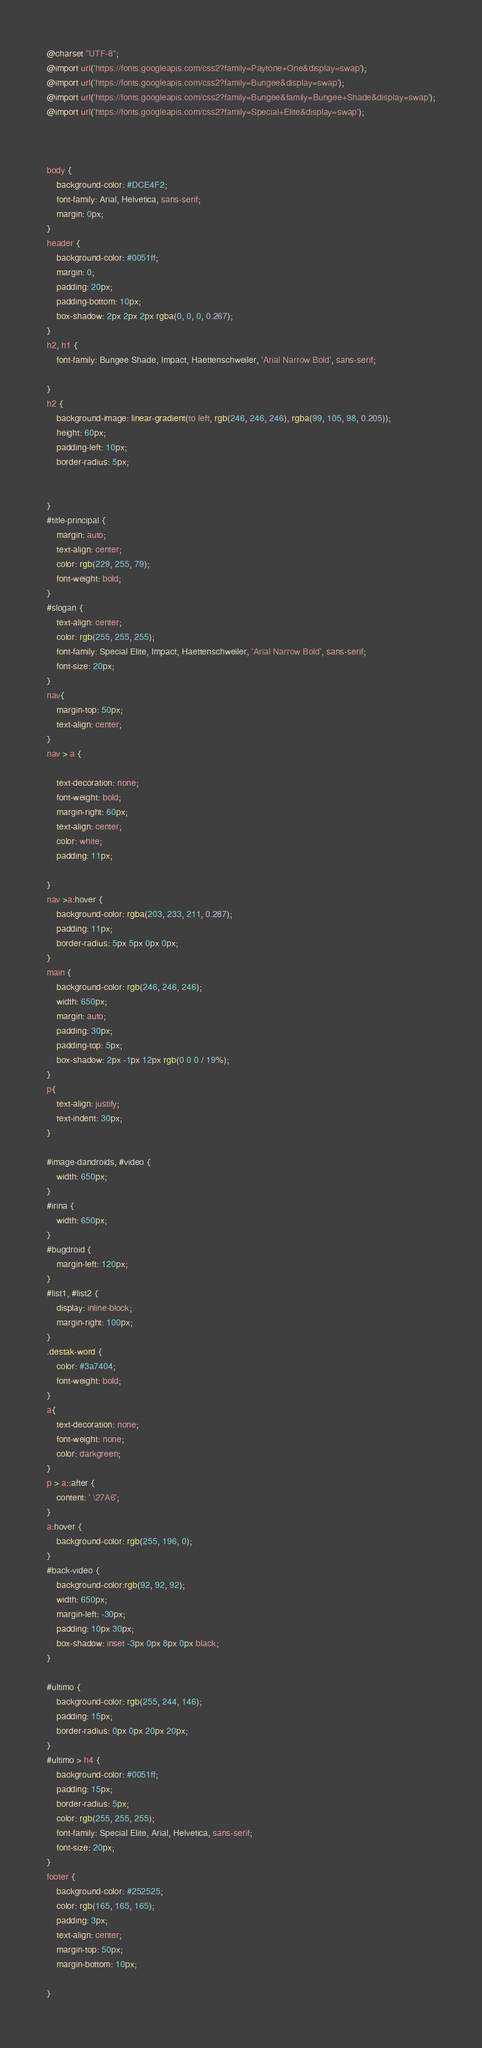Convert code to text. <code><loc_0><loc_0><loc_500><loc_500><_CSS_>@charset "UTF-8";
@import url('https://fonts.googleapis.com/css2?family=Paytone+One&display=swap');
@import url('https://fonts.googleapis.com/css2?family=Bungee&display=swap');
@import url('https://fonts.googleapis.com/css2?family=Bungee&family=Bungee+Shade&display=swap');
@import url('https://fonts.googleapis.com/css2?family=Special+Elite&display=swap');



body {
    background-color: #DCE4F2;
    font-family: Arial, Helvetica, sans-serif;
    margin: 0px;
}
header {
    background-color: #0051ff;
    margin: 0;
    padding: 20px;
    padding-bottom: 10px;
    box-shadow: 2px 2px 2px rgba(0, 0, 0, 0.267);
}
h2, h1 {
    font-family: Bungee Shade, Impact, Haettenschweiler, 'Arial Narrow Bold', sans-serif;
      
}
h2 {
    background-image: linear-gradient(to left, rgb(246, 246, 246), rgba(99, 105, 98, 0.205));
    height: 60px;
    padding-left: 10px;
    border-radius: 5px;
    
    
}
#title-principal {
    margin: auto;
    text-align: center;
    color: rgb(229, 255, 79);
    font-weight: bold;   
}
#slogan {
    text-align: center;
    color: rgb(255, 255, 255);
    font-family: Special Elite, Impact, Haettenschweiler, 'Arial Narrow Bold', sans-serif;
    font-size: 20px;
}
nav{
    margin-top: 50px;
    text-align: center;
}
nav > a {
    
    text-decoration: none;
    font-weight: bold;
    margin-right: 60px;
    text-align: center;
    color: white;
    padding: 11px;
    
}
nav >a:hover {
    background-color: rgba(203, 233, 211, 0.287);
    padding: 11px;
    border-radius: 5px 5px 0px 0px;
}
main {
    background-color: rgb(246, 246, 246);
    width: 650px;
    margin: auto;
    padding: 30px;
    padding-top: 5px;
    box-shadow: 2px -1px 12px rgb(0 0 0 / 19%);
}
p{
    text-align: justify;
    text-indent: 30px;
}

#image-dandroids, #video {
    width: 650px;
}
#irina {
    width: 650px;
}
#bugdroid {
    margin-left: 120px;
}
#list1, #list2 {
    display: inline-block;
    margin-right: 100px;
}
.destak-word {
    color: #3a7404;
    font-weight: bold;
}
a{
    text-decoration: none;
    font-weight: none;
    color: darkgreen;
}
p > a::after {
    content: ' \27A6';
}
a:hover {
    background-color: rgb(255, 196, 0);
}
#back-video {
    background-color:rgb(92, 92, 92);
    width: 650px;
    margin-left: -30px;
    padding: 10px 30px;
    box-shadow: inset -3px 0px 8px 0px black;
}

#ultimo {
    background-color: rgb(255, 244, 146);
    padding: 15px;
    border-radius: 0px 0px 20px 20px;
}
#ultimo > h4 {
    background-color: #0051ff;
    padding: 15px;
    border-radius: 5px;
    color: rgb(255, 255, 255);
    font-family: Special Elite, Arial, Helvetica, sans-serif;
    font-size: 20px;
}
footer {
    background-color: #252525;
    color: rgb(165, 165, 165);
    padding: 3px;
    text-align: center;
    margin-top: 50px;
    margin-bottom: 10px;

}
</code> 